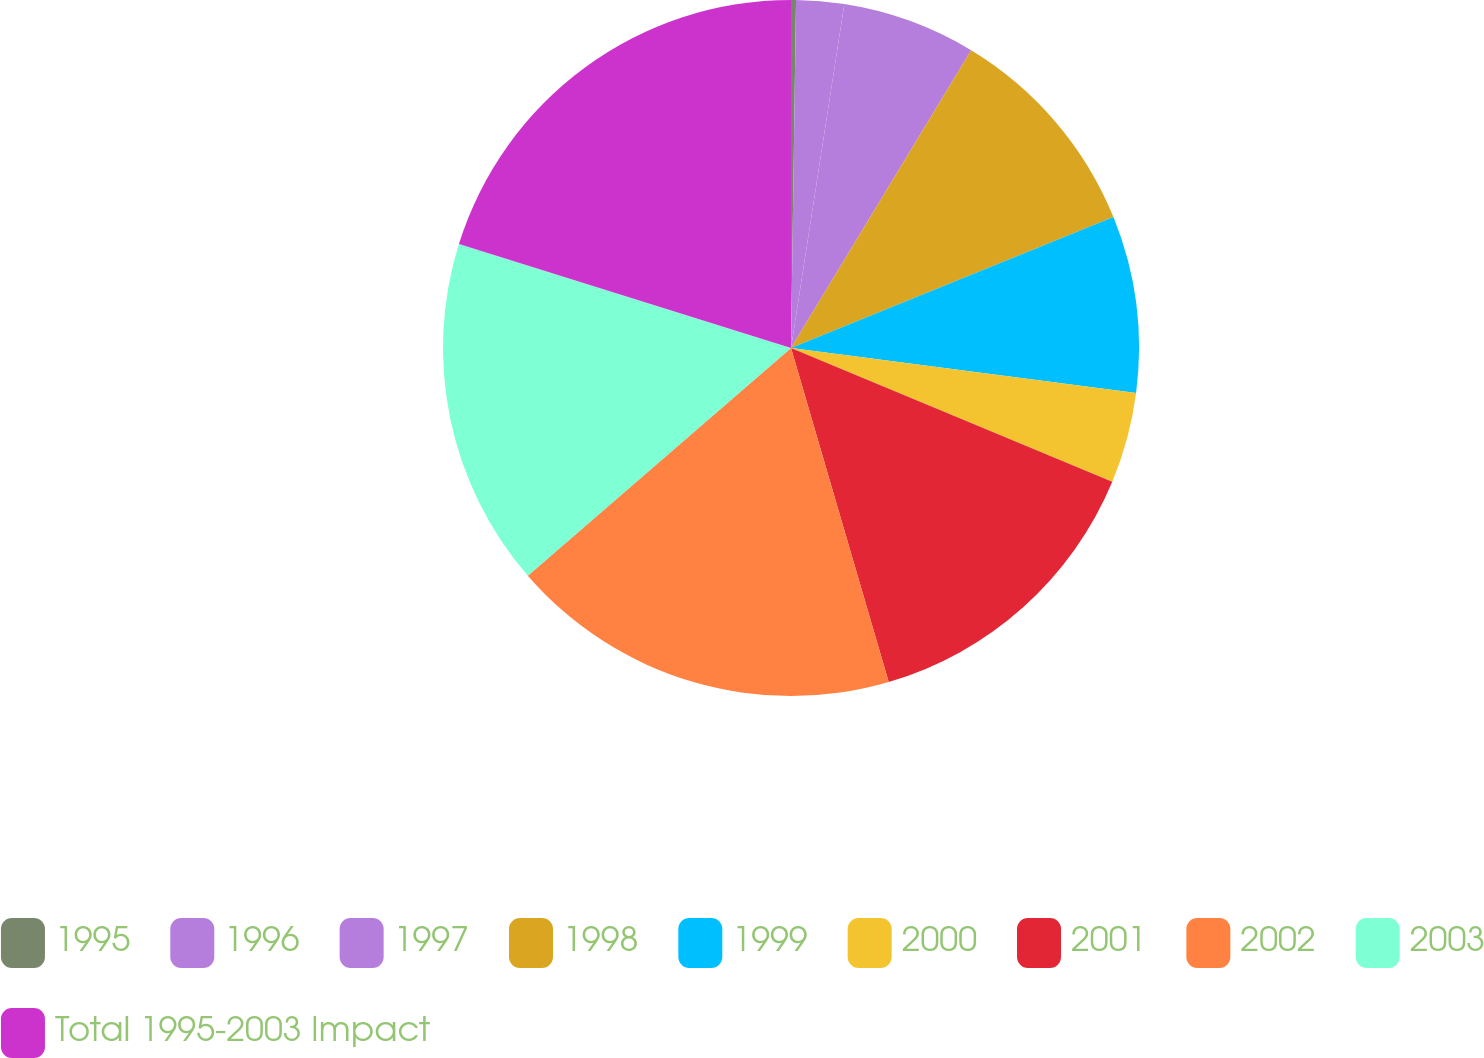Convert chart. <chart><loc_0><loc_0><loc_500><loc_500><pie_chart><fcel>1995<fcel>1996<fcel>1997<fcel>1998<fcel>1999<fcel>2000<fcel>2001<fcel>2002<fcel>2003<fcel>Total 1995-2003 Impact<nl><fcel>0.23%<fcel>2.22%<fcel>6.21%<fcel>10.2%<fcel>8.2%<fcel>4.22%<fcel>14.19%<fcel>18.18%<fcel>16.18%<fcel>20.17%<nl></chart> 